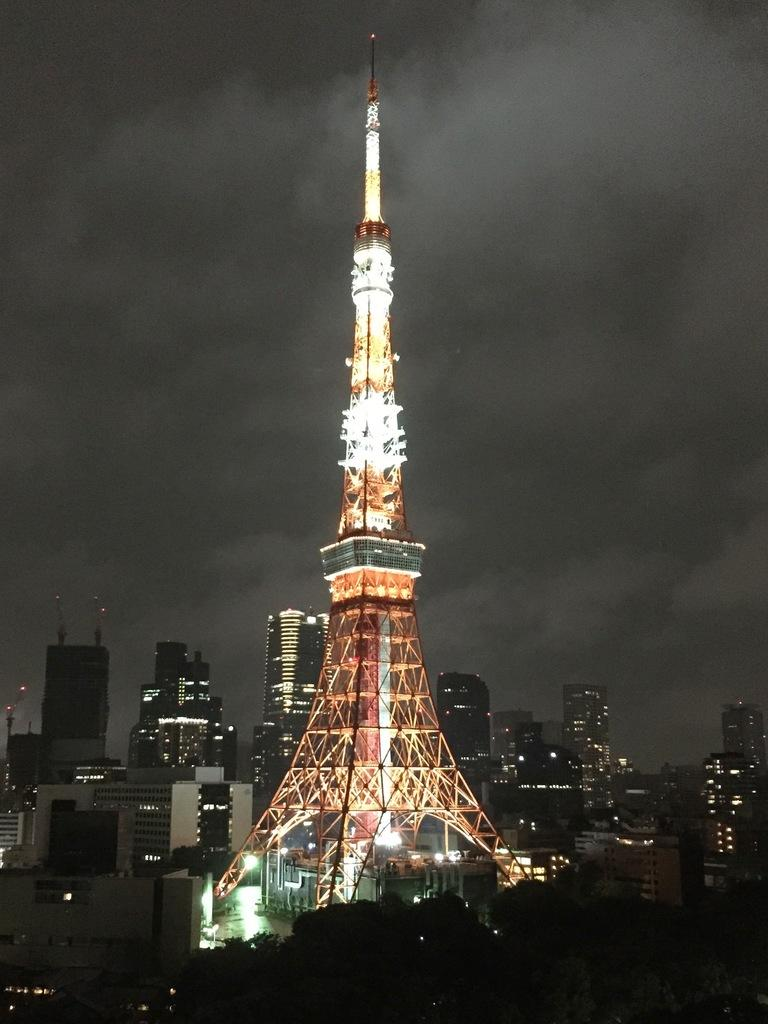What time of day was the image taken? The image was taken during nighttime. What is the main structure in the image? There is a tower in the image. What other structures are present in the image? There are buildings in the image. What feature of the tower is visible in the image? The tower has lights at the top. What can be seen in the background of the image? The sky is visible in the image. How many ladybugs can be seen on the gate in the image? There are no ladybugs or gates present in the image. What type of tray is visible on the tower in the image? There is no tray visible on the tower in the image. 